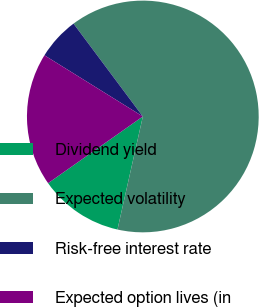Convert chart to OTSL. <chart><loc_0><loc_0><loc_500><loc_500><pie_chart><fcel>Dividend yield<fcel>Expected volatility<fcel>Risk-free interest rate<fcel>Expected option lives (in<nl><fcel>11.72%<fcel>63.72%<fcel>5.94%<fcel>18.62%<nl></chart> 